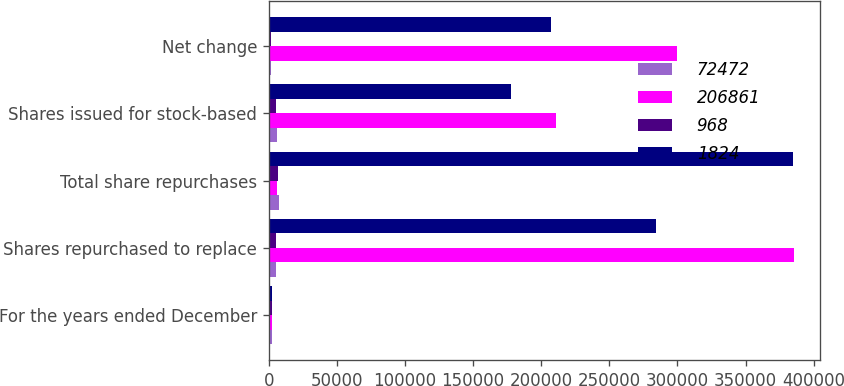<chart> <loc_0><loc_0><loc_500><loc_500><stacked_bar_chart><ecel><fcel>For the years ended December<fcel>Shares repurchased to replace<fcel>Total share repurchases<fcel>Shares issued for stock-based<fcel>Net change<nl><fcel>72472<fcel>2012<fcel>5599<fcel>7653<fcel>6233<fcel>1420<nl><fcel>206861<fcel>2012<fcel>385699<fcel>6233<fcel>210924<fcel>299706<nl><fcel>968<fcel>2011<fcel>5179<fcel>7082<fcel>5258<fcel>1824<nl><fcel>1824<fcel>2011<fcel>284500<fcel>384515<fcel>177654<fcel>206861<nl></chart> 